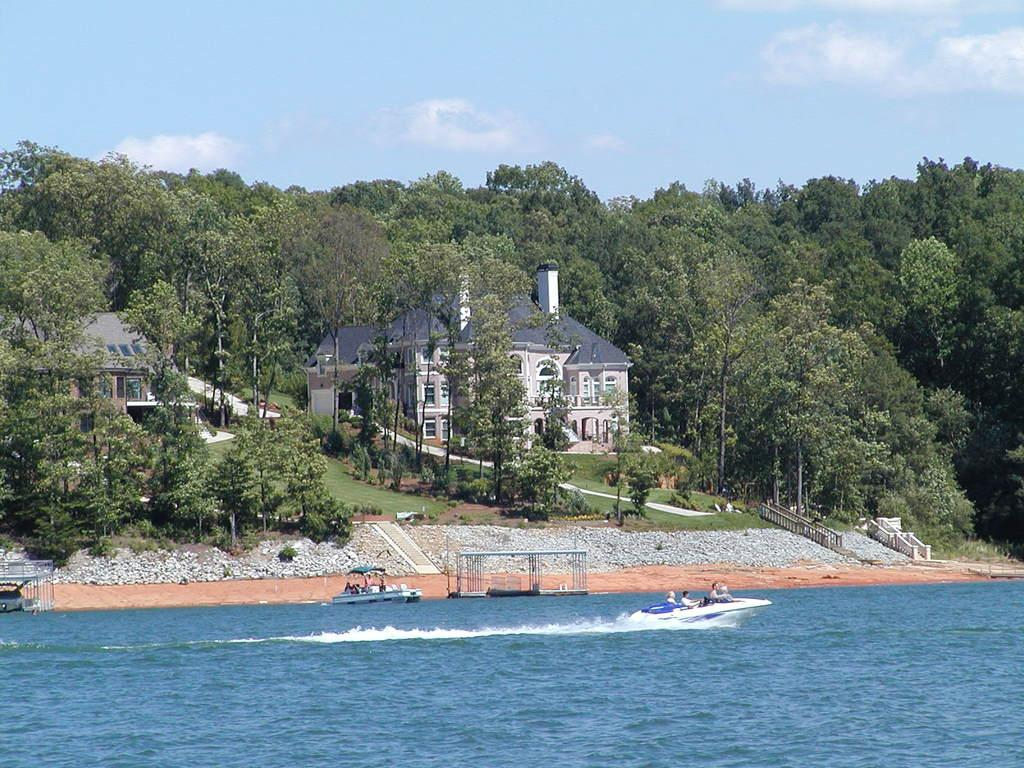What is the main feature of the image? The main feature of the image is water. What is floating on the water? There is a boat in the image. What else can be seen near the water? There are stones, grass, trees, and buildings visible in the image. What is visible in the sky? The sky is visible in the image, and there are clouds present. How does the water control the sneezing of the trees in the image? The water does not control the sneezing of the trees in the image, as trees do not sneeze. 